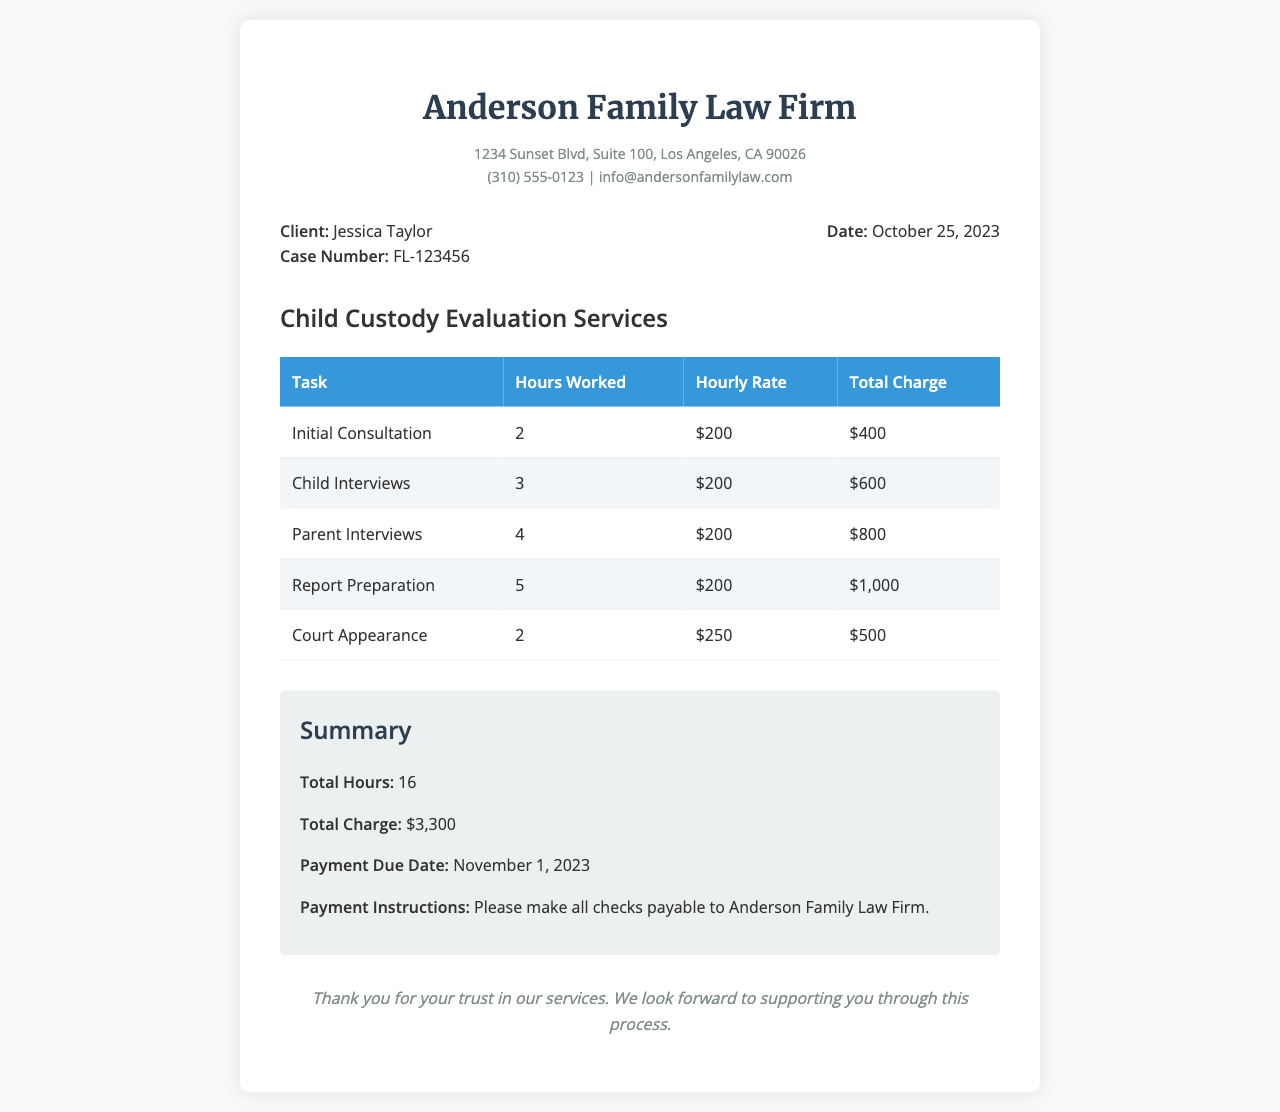what is the client’s name? The client's name is clearly stated in the document under the client info section.
Answer: Jessica Taylor what is the case number? The case number is listed next to the client's name in the client info section.
Answer: FL-123456 what is the date of the billing statement? The date is shown in the client info section, indicating when the billing statement was issued.
Answer: October 25, 2023 what is the total hours worked? The total hours worked can be found in the summary section, which aggregates the hours from all tasks.
Answer: 16 what is the total charge for the services? The total charge is also provided in the summary section, summarizing the charges for all services rendered.
Answer: $3,300 how much was charged for Court Appearance? This amount is specified in the detailed table, showing charges for each task performed.
Answer: $500 what is the hourly rate for child interviews? The hourly rate for this specific task is mentioned alongside the hours worked and total charge in the breakdown.
Answer: $200 when is the payment due date? The payment due date is explicitly stated in the summary section of the document.
Answer: November 1, 2023 who should checks be made payable to? This information can be found in the payment instructions section at the end of the document.
Answer: Anderson Family Law Firm 